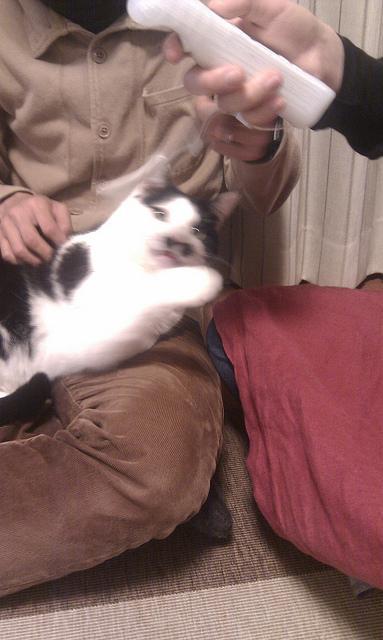What year was this video game console first released?
From the following set of four choices, select the accurate answer to respond to the question.
Options: 2006, 2021, 1999, 2012. 2006. 